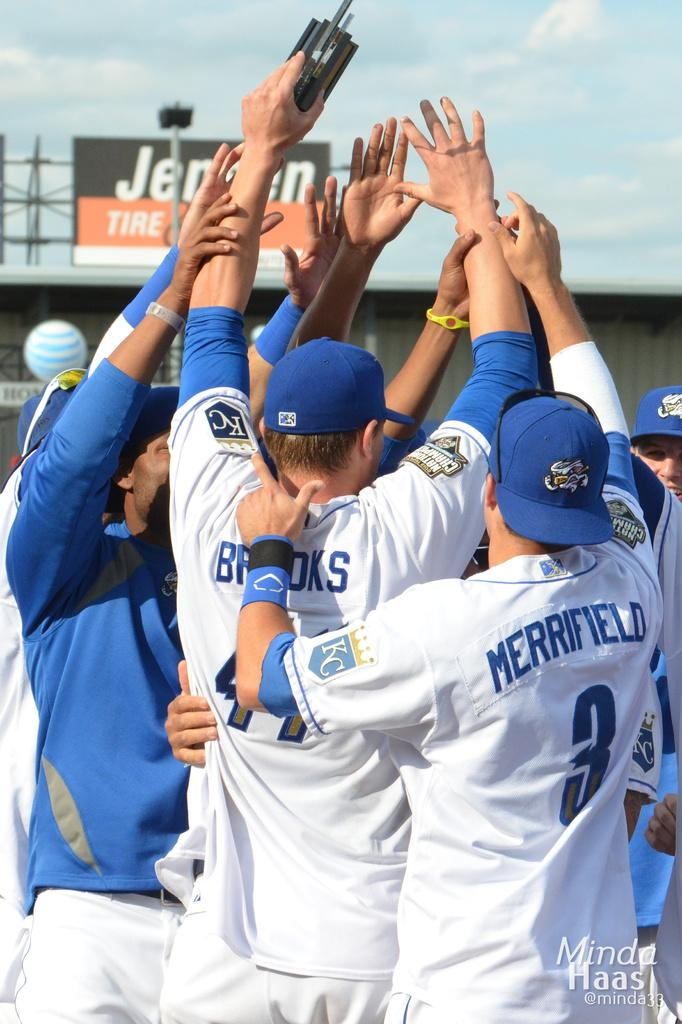<image>
Give a short and clear explanation of the subsequent image. A man has a shirt with Merrifield on the back. 